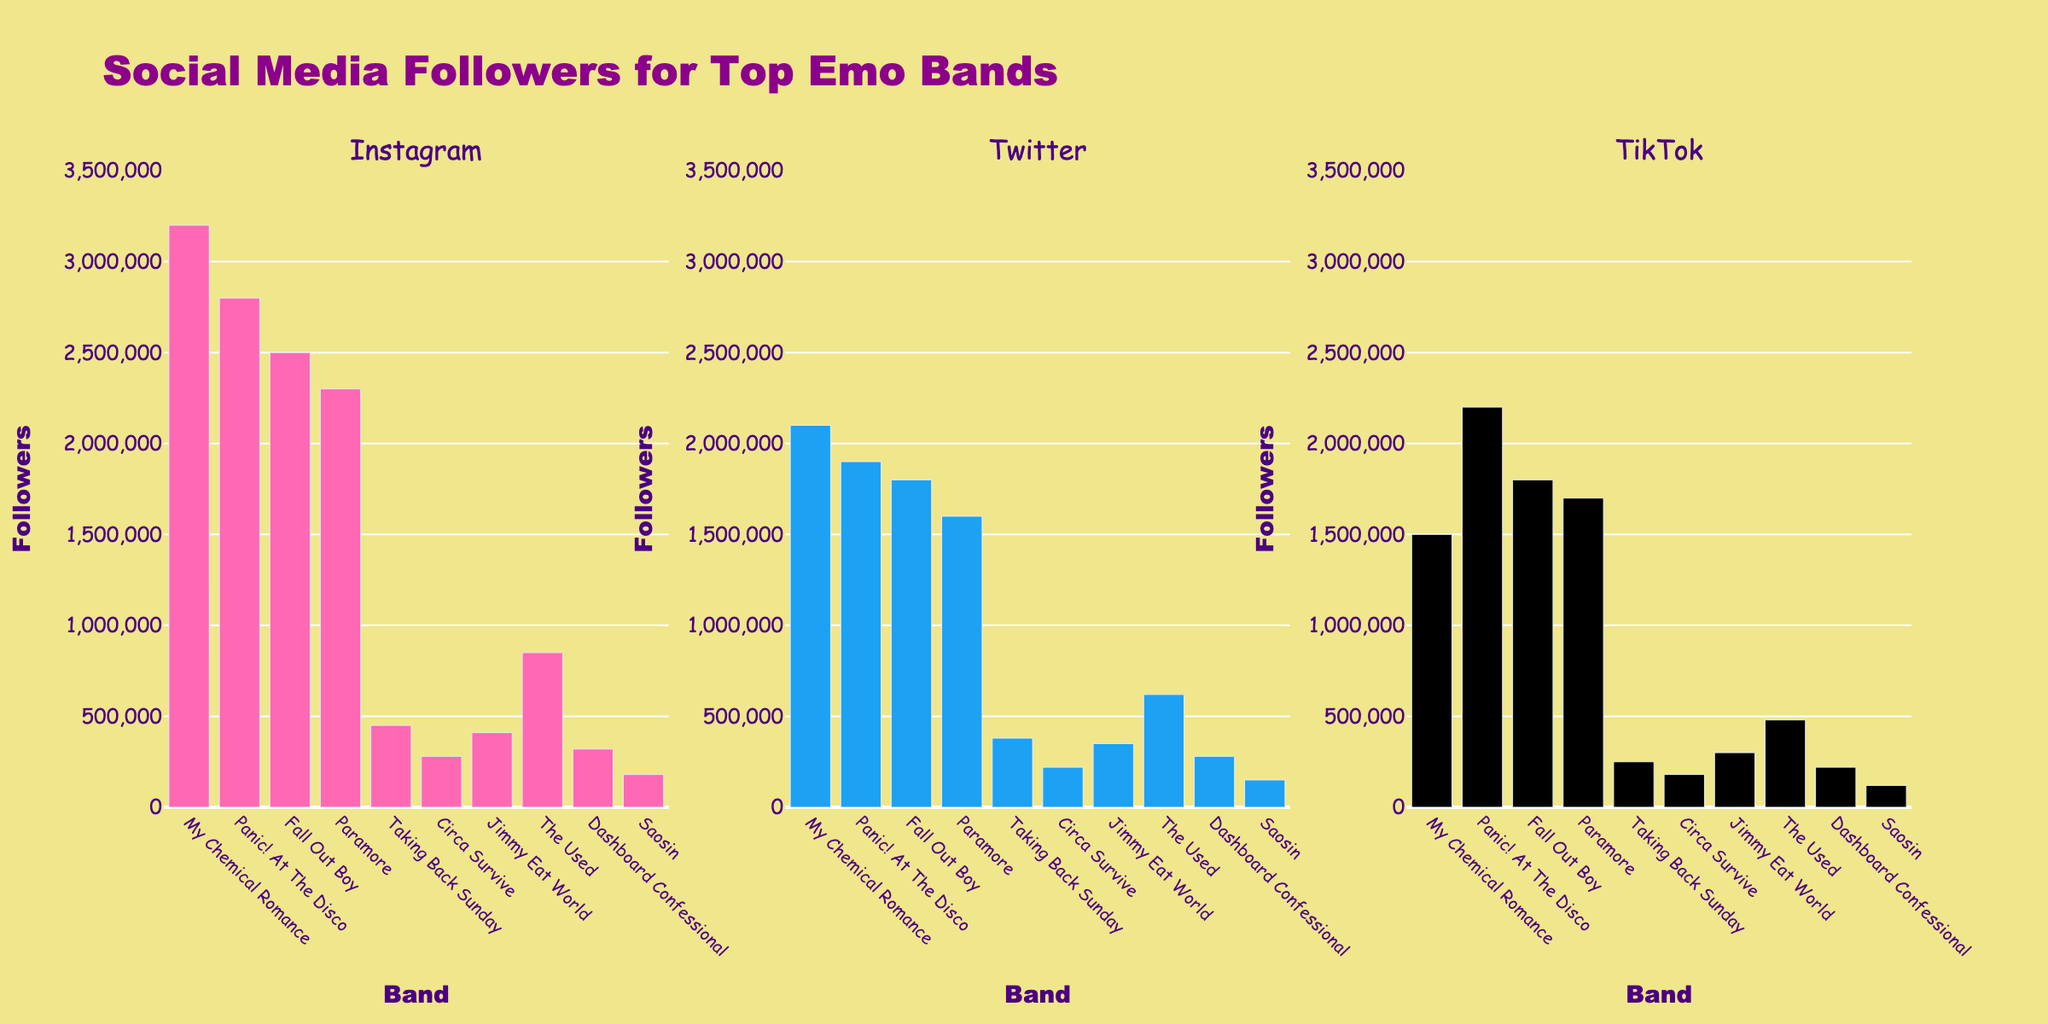What is the title of the figure? The title is usually displayed prominently at the top of the figure. In this case, it is clearly visible.
Answer: Social Media Followers for Top Emo Bands Which band has the most Instagram followers? By examining the Instagram subplot, we see the tallest bar corresponds to My Chemical Romance.
Answer: My Chemical Romance Which band has the least followers on Twitter? By checking the heights of the bars in the Twitter subplot, Circa Survive has the shortest bar.
Answer: Circa Survive What's the combined number of followers on TikTok for My Chemical Romance and Panic! At The Disco? Add the TikTok followers for My Chemical Romance (1,500,000) and Panic! At The Disco (2,200,000).
Answer: 3,700,000 How do the number of followers on Instagram for Paramore compare to Fall Out Boy? Check the heights of the Instagram bars. Fall Out Boy (2,500,000) has more followers than Paramore (2,300,000).
Answer: Fall Out Boy has more followers Which band has the most followers on TikTok? Looking at the TikTok subplot, the tallest bar is for Panic! At The Disco.
Answer: Panic! At The Disco Which band appears to have similar number of followers across all three platforms? Dashboard Confessional shows a relative consistency in the heights of its bars across all platforms.
Answer: Dashboard Confessional What is the total number of Instagram followers for all listed bands? Sum up each band's Instagram followers from the data. It totals to 8,640,000.
Answer: 8,640,000 What is the average number of Twitter followers across all bands? Sum the Twitter followers (13,200,000) and divide by the number of bands (10).
Answer: 1,320,000 Compare the number of TikTok followers for Circa Survive and Saosin. Who has more and by how much? Circa Survive has 180,000 and Saosin has 120,000. Subtract Saosin's followers from Circa Survive's followers.
Answer: Circa Survive has 60,000 more followers 